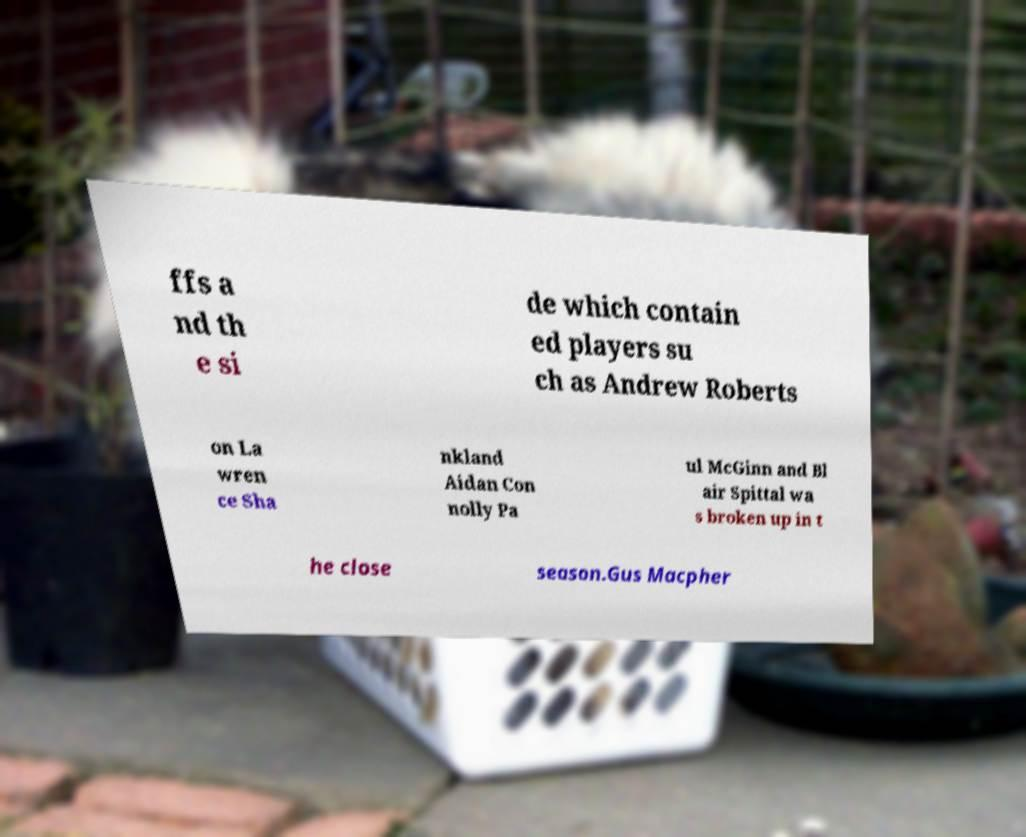For documentation purposes, I need the text within this image transcribed. Could you provide that? ffs a nd th e si de which contain ed players su ch as Andrew Roberts on La wren ce Sha nkland Aidan Con nolly Pa ul McGinn and Bl air Spittal wa s broken up in t he close season.Gus Macpher 